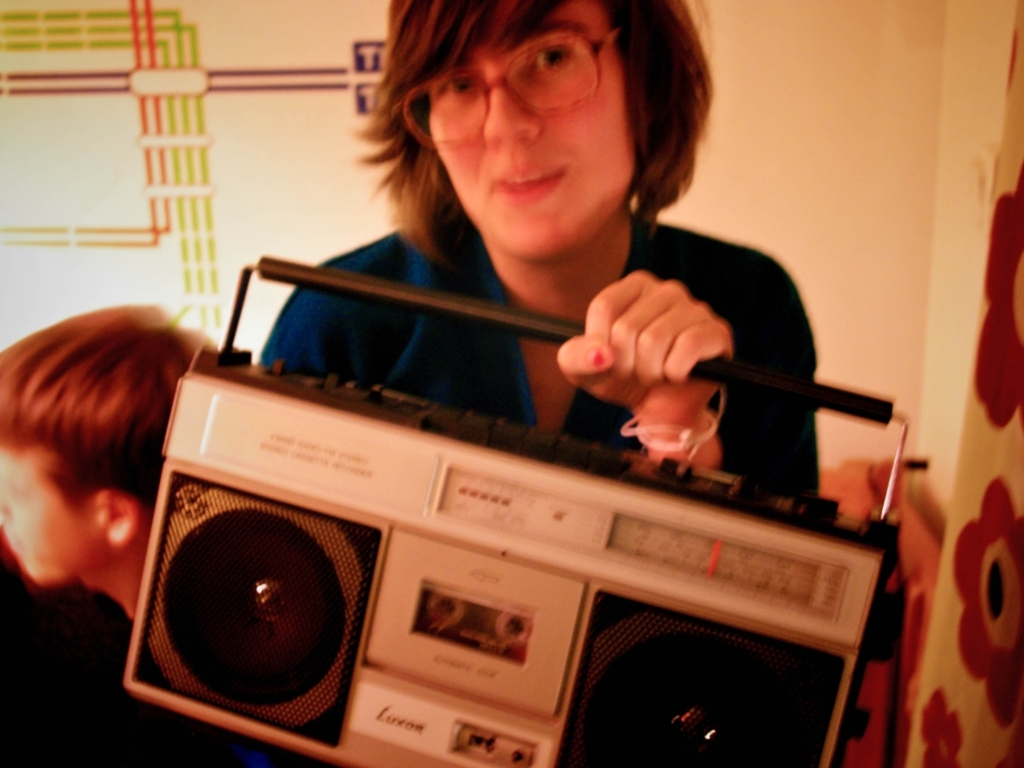What kind of atmosphere does the image convey? The image exudes a casual, relaxed atmosphere, possibly from a social gathering or an intimate home setting. The subject's engagement with the music player adds a layer of personal interest or hobbyist enjoyment to the scene. Does the image tell us anything about the person's musical taste? The specific musical taste of the person isn't clear from the image alone, as it doesn't reveal what's playing on the cassette player. However, the use of such a device might suggest an appreciation for classic or analog music formats. 